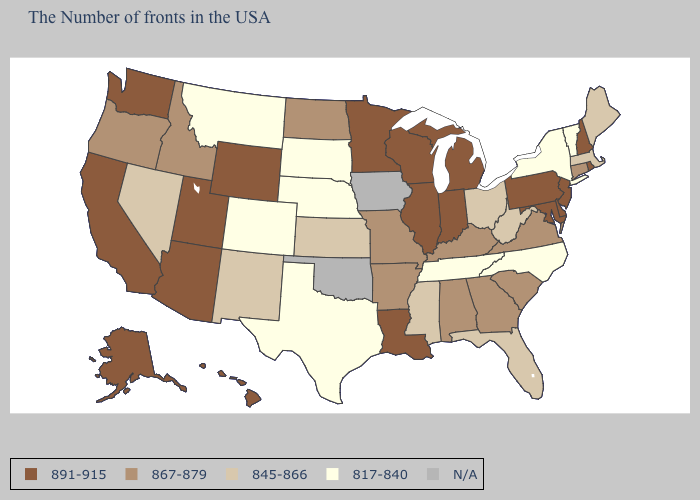Does Connecticut have the highest value in the Northeast?
Answer briefly. No. What is the value of New York?
Answer briefly. 817-840. What is the value of South Dakota?
Quick response, please. 817-840. What is the highest value in states that border Pennsylvania?
Keep it brief. 891-915. What is the highest value in the USA?
Answer briefly. 891-915. What is the value of Connecticut?
Concise answer only. 867-879. Does Louisiana have the highest value in the South?
Quick response, please. Yes. What is the lowest value in states that border Indiana?
Give a very brief answer. 845-866. Which states have the lowest value in the MidWest?
Give a very brief answer. Nebraska, South Dakota. What is the value of Wyoming?
Quick response, please. 891-915. Among the states that border Indiana , does Illinois have the highest value?
Give a very brief answer. Yes. Among the states that border Pennsylvania , does Delaware have the highest value?
Give a very brief answer. Yes. What is the value of Idaho?
Write a very short answer. 867-879. What is the value of Vermont?
Keep it brief. 817-840. 